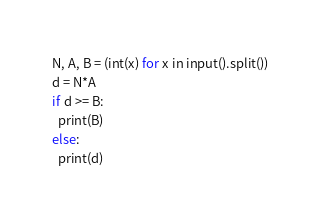Convert code to text. <code><loc_0><loc_0><loc_500><loc_500><_Python_>N, A, B = (int(x) for x in input().split())
d = N*A
if d >= B:
  print(B)
else:
  print(d)</code> 